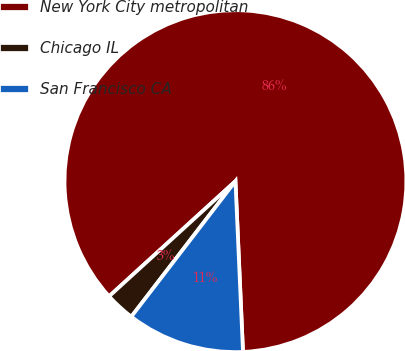Convert chart. <chart><loc_0><loc_0><loc_500><loc_500><pie_chart><fcel>New York City metropolitan<fcel>Chicago IL<fcel>San Francisco CA<nl><fcel>86.06%<fcel>2.81%<fcel>11.13%<nl></chart> 